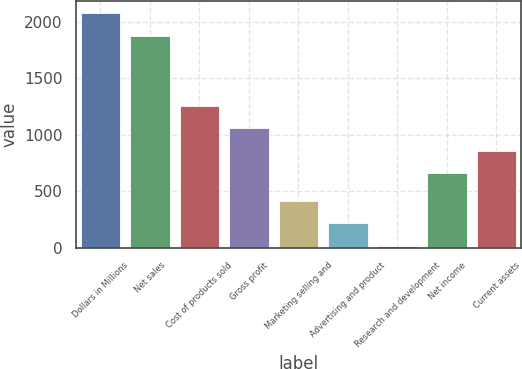Convert chart to OTSL. <chart><loc_0><loc_0><loc_500><loc_500><bar_chart><fcel>Dollars in Millions<fcel>Net sales<fcel>Cost of products sold<fcel>Gross profit<fcel>Marketing selling and<fcel>Advertising and product<fcel>Research and development<fcel>Net income<fcel>Current assets<nl><fcel>2078.4<fcel>1879<fcel>1257.2<fcel>1057.8<fcel>414.8<fcel>215.4<fcel>16<fcel>659<fcel>858.4<nl></chart> 